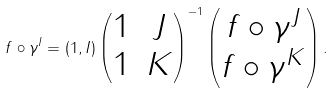<formula> <loc_0><loc_0><loc_500><loc_500>f \circ \gamma ^ { I } = ( 1 , I ) \left ( \begin{matrix} 1 & J \\ 1 & K \end{matrix} \right ) ^ { - 1 } \left ( \begin{matrix} f \circ \gamma ^ { J } \\ f \circ \gamma ^ { K } \end{matrix} \right ) .</formula> 